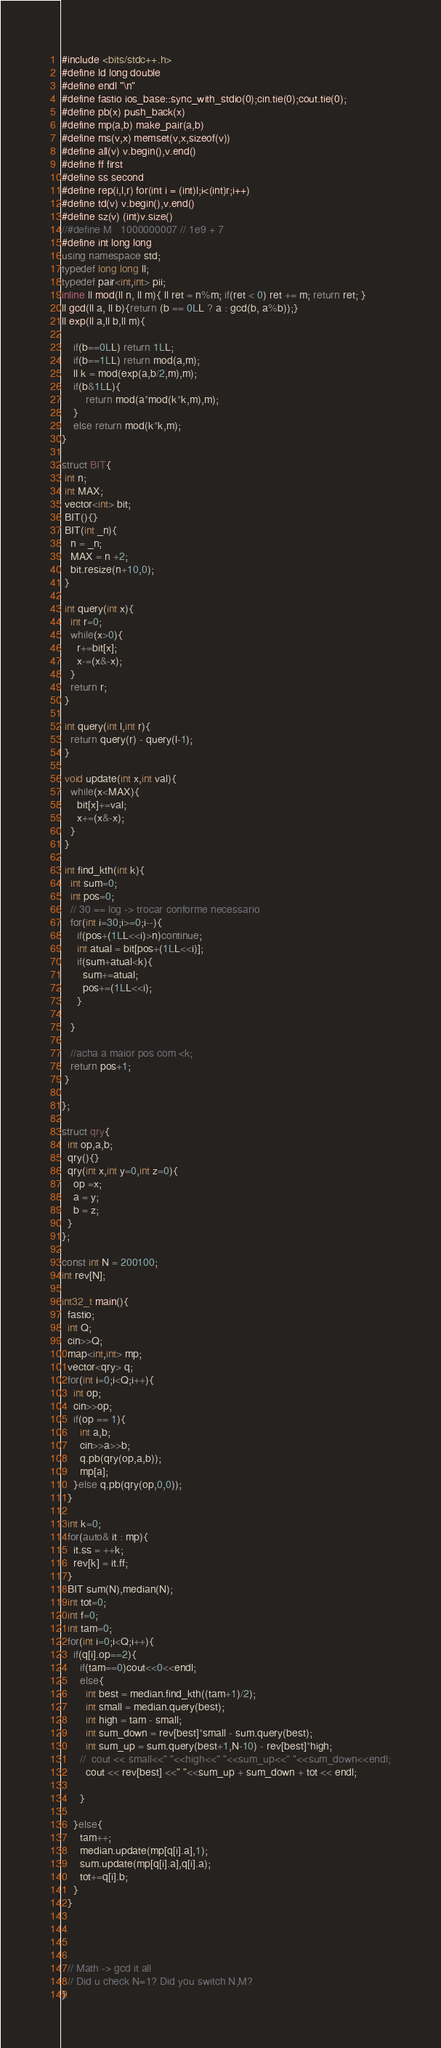<code> <loc_0><loc_0><loc_500><loc_500><_C++_>#include <bits/stdc++.h>
#define ld long double
#define endl "\n"
#define fastio ios_base::sync_with_stdio(0);cin.tie(0);cout.tie(0);
#define pb(x) push_back(x)
#define mp(a,b) make_pair(a,b)
#define ms(v,x) memset(v,x,sizeof(v))
#define all(v) v.begin(),v.end()
#define ff first
#define ss second
#define rep(i,l,r) for(int i = (int)l;i<(int)r;i++)
#define td(v) v.begin(),v.end()
#define sz(v) (int)v.size()
//#define M   1000000007 // 1e9 + 7
#define int long long
using namespace std;
typedef long long ll;
typedef pair<int,int> pii;
inline ll mod(ll n, ll m){ ll ret = n%m; if(ret < 0) ret += m; return ret; }
ll gcd(ll a, ll b){return (b == 0LL ? a : gcd(b, a%b));}
ll exp(ll a,ll b,ll m){
    
    if(b==0LL) return 1LL;
    if(b==1LL) return mod(a,m);
    ll k = mod(exp(a,b/2,m),m);
    if(b&1LL){
        return mod(a*mod(k*k,m),m);
    }
    else return mod(k*k,m);
}

struct BIT{
 int n;
 int MAX;
 vector<int> bit;
 BIT(){}
 BIT(int _n){
   n = _n;
   MAX = n +2;
   bit.resize(n+10,0);
 }
 
 int query(int x){
   int r=0;
   while(x>0){
     r+=bit[x];
     x-=(x&-x);
   }
   return r;
 }
 
 int query(int l,int r){
   return query(r) - query(l-1);
 }
 
 void update(int x,int val){
   while(x<MAX){
     bit[x]+=val;
     x+=(x&-x);
   }
 }
 
 int find_kth(int k){
   int sum=0;
   int pos=0;
   // 30 == log -> trocar conforme necessario
   for(int i=30;i>=0;i--){
     if(pos+(1LL<<i)>n)continue;
     int atual = bit[pos+(1LL<<i)];
     if(sum+atual<k){
       sum+=atual;
       pos+=(1LL<<i);
     }
     
   }
   
   //acha a maior pos com <k;
   return pos+1;
 }
  
};

struct qry{
  int op,a,b;
  qry(){}
  qry(int x,int y=0,int z=0){
    op =x;
    a = y;
    b = z;
  }
};

const int N = 200100;
int rev[N];

int32_t main(){
  fastio;
  int Q;
  cin>>Q;
  map<int,int> mp;
  vector<qry> q;
  for(int i=0;i<Q;i++){
    int op;
    cin>>op;
    if(op == 1){
      int a,b;
      cin>>a>>b;
      q.pb(qry(op,a,b));
      mp[a];
    }else q.pb(qry(op,0,0));
  }

  int k=0;
  for(auto& it : mp){
    it.ss = ++k;
    rev[k] = it.ff;
  }
  BIT sum(N),median(N);
  int tot=0;
  int f=0;
  int tam=0;
  for(int i=0;i<Q;i++){
    if(q[i].op==2){
      if(tam==0)cout<<0<<endl;
      else{
        int best = median.find_kth((tam+1)/2);
        int small = median.query(best);
        int high = tam - small;
        int sum_down = rev[best]*small - sum.query(best);
        int sum_up = sum.query(best+1,N-10) - rev[best]*high;
      //  cout << small<<" "<<high<<" "<<sum_up<<" "<<sum_down<<endl;
        cout << rev[best] <<" "<<sum_up + sum_down + tot << endl;

      }

    }else{
      tam++;
      median.update(mp[q[i].a],1);
      sum.update(mp[q[i].a],q[i].a);
      tot+=q[i].b;
    }
  }




  // Math -> gcd it all
  // Did u check N=1? Did you switch N,M?
}</code> 